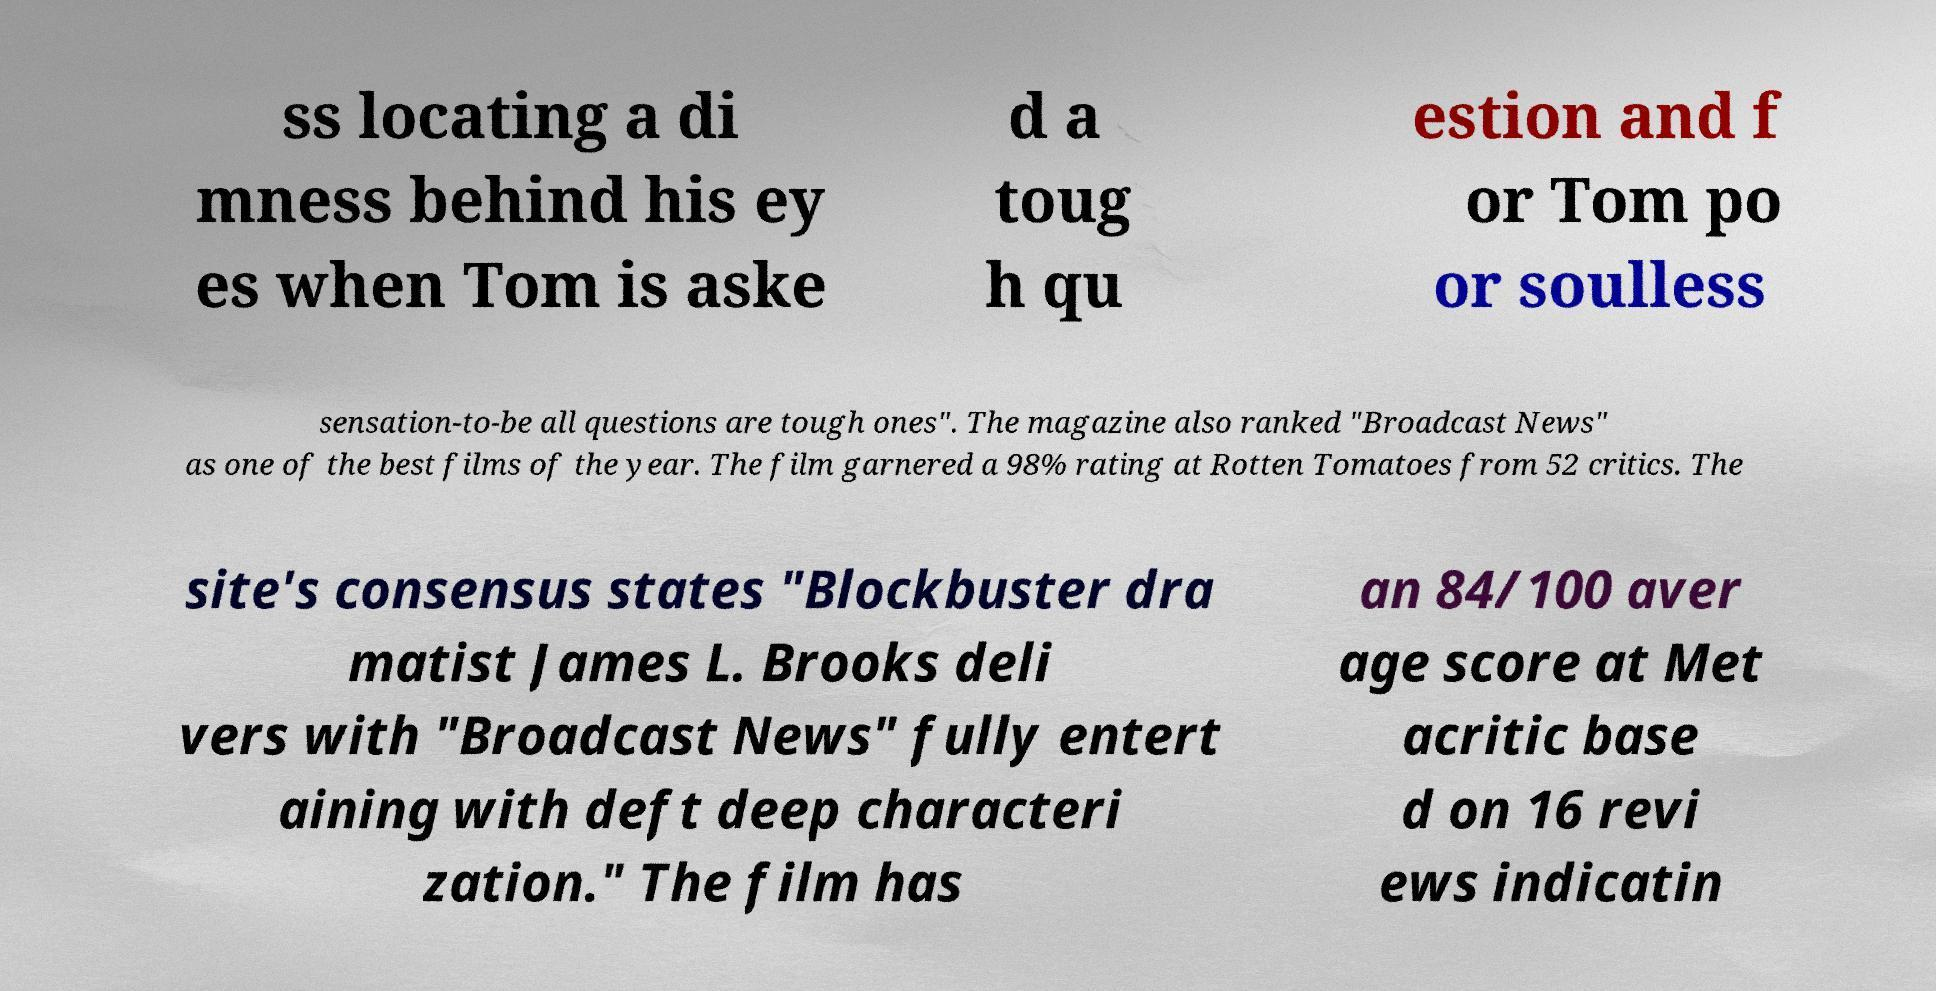What messages or text are displayed in this image? I need them in a readable, typed format. ss locating a di mness behind his ey es when Tom is aske d a toug h qu estion and f or Tom po or soulless sensation-to-be all questions are tough ones". The magazine also ranked "Broadcast News" as one of the best films of the year. The film garnered a 98% rating at Rotten Tomatoes from 52 critics. The site's consensus states "Blockbuster dra matist James L. Brooks deli vers with "Broadcast News" fully entert aining with deft deep characteri zation." The film has an 84/100 aver age score at Met acritic base d on 16 revi ews indicatin 